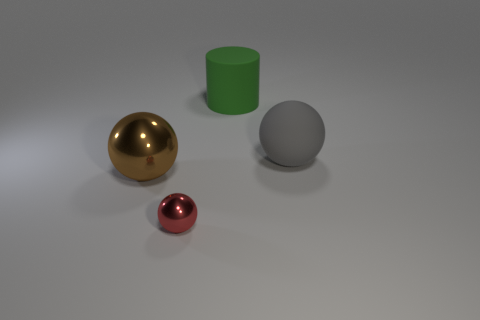Add 1 gray cylinders. How many objects exist? 5 Subtract all spheres. How many objects are left? 1 Subtract all brown shiny spheres. Subtract all red balls. How many objects are left? 2 Add 1 small red things. How many small red things are left? 2 Add 4 large yellow rubber cylinders. How many large yellow rubber cylinders exist? 4 Subtract 1 green cylinders. How many objects are left? 3 